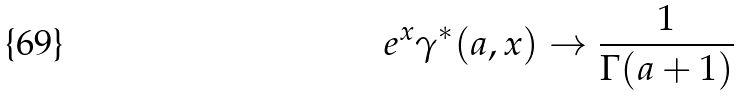Convert formula to latex. <formula><loc_0><loc_0><loc_500><loc_500>e ^ { x } \gamma ^ { * } ( a , x ) \rightarrow \frac { 1 } { \Gamma ( a + 1 ) }</formula> 